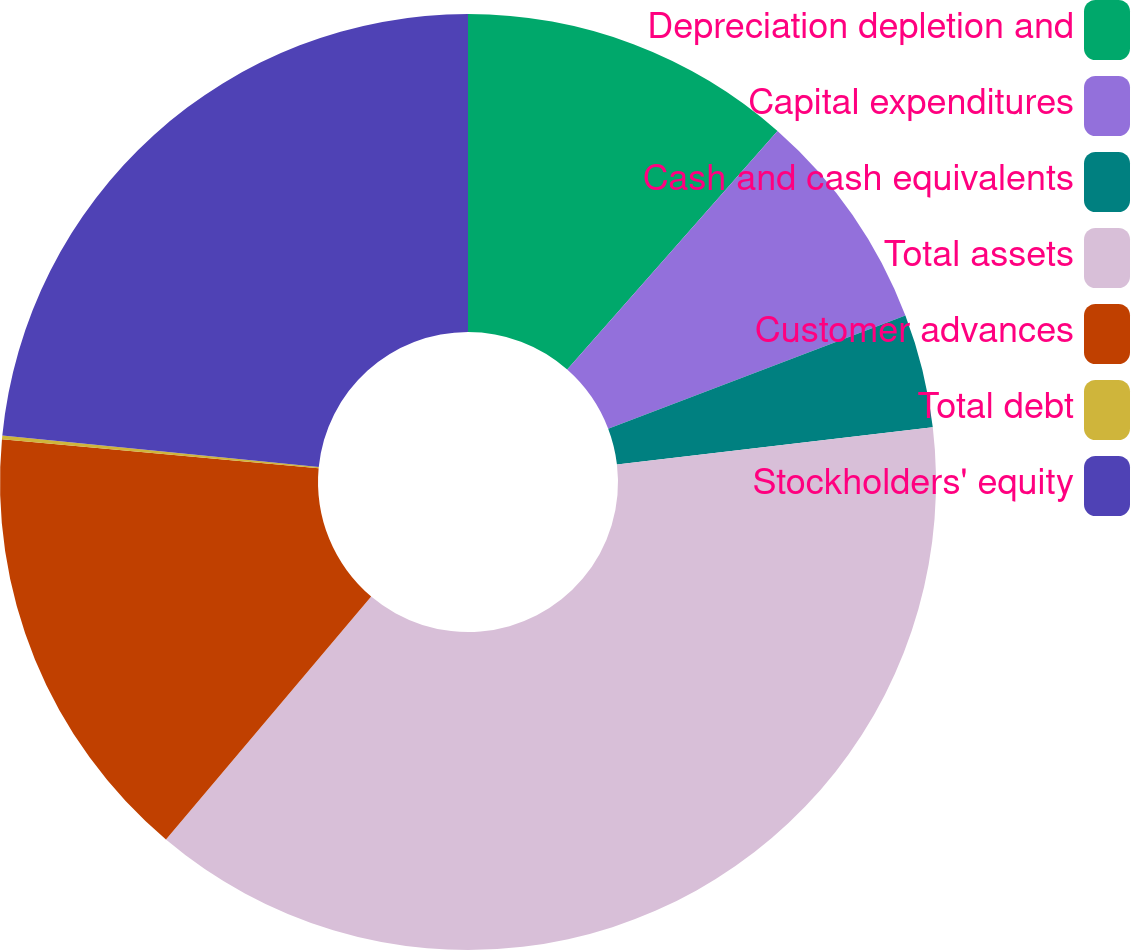Convert chart. <chart><loc_0><loc_0><loc_500><loc_500><pie_chart><fcel>Depreciation depletion and<fcel>Capital expenditures<fcel>Cash and cash equivalents<fcel>Total assets<fcel>Customer advances<fcel>Total debt<fcel>Stockholders' equity<nl><fcel>11.5%<fcel>7.71%<fcel>3.92%<fcel>38.03%<fcel>15.29%<fcel>0.13%<fcel>23.41%<nl></chart> 